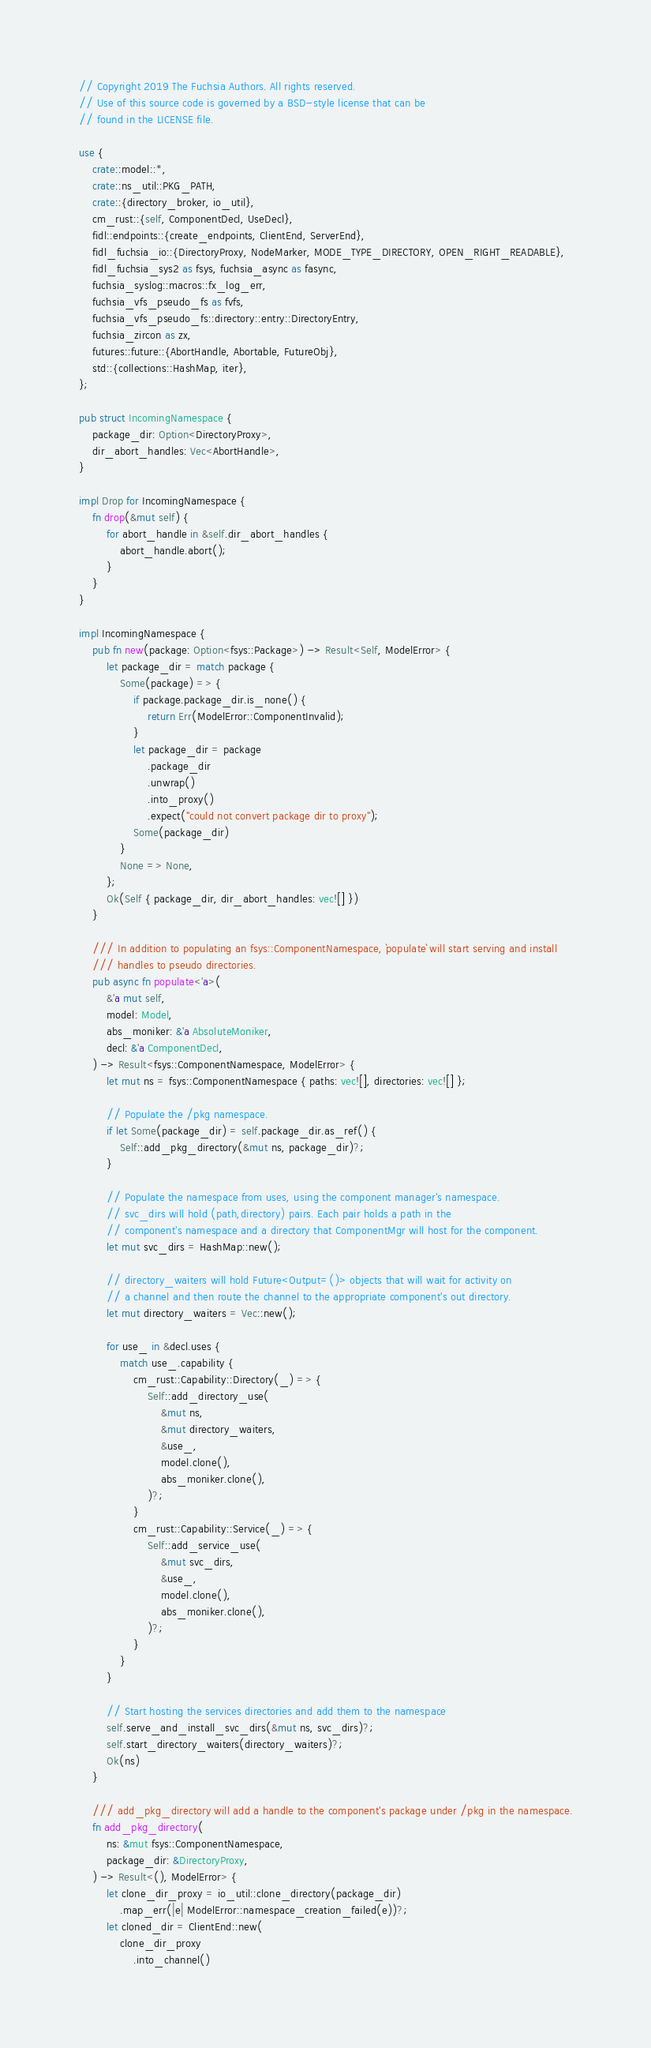Convert code to text. <code><loc_0><loc_0><loc_500><loc_500><_Rust_>// Copyright 2019 The Fuchsia Authors. All rights reserved.
// Use of this source code is governed by a BSD-style license that can be
// found in the LICENSE file.

use {
    crate::model::*,
    crate::ns_util::PKG_PATH,
    crate::{directory_broker, io_util},
    cm_rust::{self, ComponentDecl, UseDecl},
    fidl::endpoints::{create_endpoints, ClientEnd, ServerEnd},
    fidl_fuchsia_io::{DirectoryProxy, NodeMarker, MODE_TYPE_DIRECTORY, OPEN_RIGHT_READABLE},
    fidl_fuchsia_sys2 as fsys, fuchsia_async as fasync,
    fuchsia_syslog::macros::fx_log_err,
    fuchsia_vfs_pseudo_fs as fvfs,
    fuchsia_vfs_pseudo_fs::directory::entry::DirectoryEntry,
    fuchsia_zircon as zx,
    futures::future::{AbortHandle, Abortable, FutureObj},
    std::{collections::HashMap, iter},
};

pub struct IncomingNamespace {
    package_dir: Option<DirectoryProxy>,
    dir_abort_handles: Vec<AbortHandle>,
}

impl Drop for IncomingNamespace {
    fn drop(&mut self) {
        for abort_handle in &self.dir_abort_handles {
            abort_handle.abort();
        }
    }
}

impl IncomingNamespace {
    pub fn new(package: Option<fsys::Package>) -> Result<Self, ModelError> {
        let package_dir = match package {
            Some(package) => {
                if package.package_dir.is_none() {
                    return Err(ModelError::ComponentInvalid);
                }
                let package_dir = package
                    .package_dir
                    .unwrap()
                    .into_proxy()
                    .expect("could not convert package dir to proxy");
                Some(package_dir)
            }
            None => None,
        };
        Ok(Self { package_dir, dir_abort_handles: vec![] })
    }

    /// In addition to populating an fsys::ComponentNamespace, `populate` will start serving and install
    /// handles to pseudo directories.
    pub async fn populate<'a>(
        &'a mut self,
        model: Model,
        abs_moniker: &'a AbsoluteMoniker,
        decl: &'a ComponentDecl,
    ) -> Result<fsys::ComponentNamespace, ModelError> {
        let mut ns = fsys::ComponentNamespace { paths: vec![], directories: vec![] };

        // Populate the /pkg namespace.
        if let Some(package_dir) = self.package_dir.as_ref() {
            Self::add_pkg_directory(&mut ns, package_dir)?;
        }

        // Populate the namespace from uses, using the component manager's namespace.
        // svc_dirs will hold (path,directory) pairs. Each pair holds a path in the
        // component's namespace and a directory that ComponentMgr will host for the component.
        let mut svc_dirs = HashMap::new();

        // directory_waiters will hold Future<Output=()> objects that will wait for activity on
        // a channel and then route the channel to the appropriate component's out directory.
        let mut directory_waiters = Vec::new();

        for use_ in &decl.uses {
            match use_.capability {
                cm_rust::Capability::Directory(_) => {
                    Self::add_directory_use(
                        &mut ns,
                        &mut directory_waiters,
                        &use_,
                        model.clone(),
                        abs_moniker.clone(),
                    )?;
                }
                cm_rust::Capability::Service(_) => {
                    Self::add_service_use(
                        &mut svc_dirs,
                        &use_,
                        model.clone(),
                        abs_moniker.clone(),
                    )?;
                }
            }
        }

        // Start hosting the services directories and add them to the namespace
        self.serve_and_install_svc_dirs(&mut ns, svc_dirs)?;
        self.start_directory_waiters(directory_waiters)?;
        Ok(ns)
    }

    /// add_pkg_directory will add a handle to the component's package under /pkg in the namespace.
    fn add_pkg_directory(
        ns: &mut fsys::ComponentNamespace,
        package_dir: &DirectoryProxy,
    ) -> Result<(), ModelError> {
        let clone_dir_proxy = io_util::clone_directory(package_dir)
            .map_err(|e| ModelError::namespace_creation_failed(e))?;
        let cloned_dir = ClientEnd::new(
            clone_dir_proxy
                .into_channel()</code> 